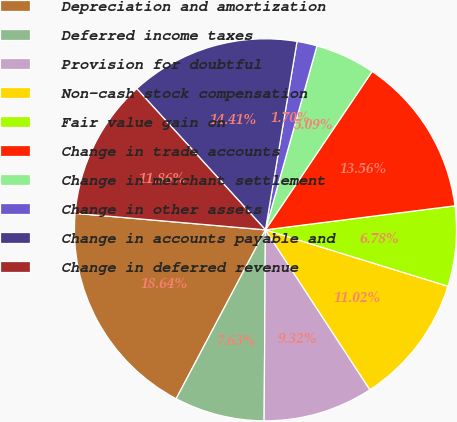Convert chart. <chart><loc_0><loc_0><loc_500><loc_500><pie_chart><fcel>Depreciation and amortization<fcel>Deferred income taxes<fcel>Provision for doubtful<fcel>Non-cash stock compensation<fcel>Fair value gain on<fcel>Change in trade accounts<fcel>Change in merchant settlement<fcel>Change in other assets<fcel>Change in accounts payable and<fcel>Change in deferred revenue<nl><fcel>18.64%<fcel>7.63%<fcel>9.32%<fcel>11.02%<fcel>6.78%<fcel>13.56%<fcel>5.09%<fcel>1.7%<fcel>14.41%<fcel>11.86%<nl></chart> 